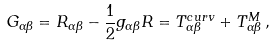Convert formula to latex. <formula><loc_0><loc_0><loc_500><loc_500>G _ { \alpha \beta } = R _ { \alpha \beta } - \frac { 1 } { 2 } g _ { \alpha \beta } R = T ^ { c u r v } _ { \alpha \beta } + T ^ { M } _ { \alpha \beta } \, ,</formula> 